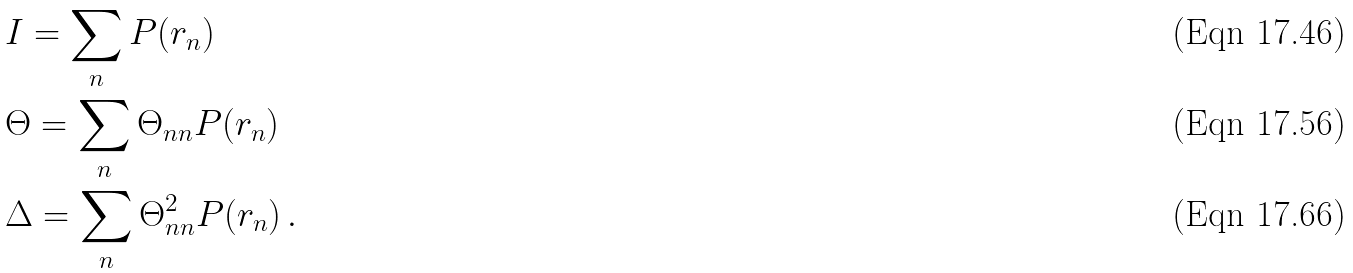<formula> <loc_0><loc_0><loc_500><loc_500>& I = \sum _ { n } P ( r _ { n } ) \\ & \Theta = \sum _ { n } \Theta _ { n n } P ( r _ { n } ) \\ & \Delta = \sum _ { n } \Theta _ { n n } ^ { 2 } P ( r _ { n } ) \, .</formula> 